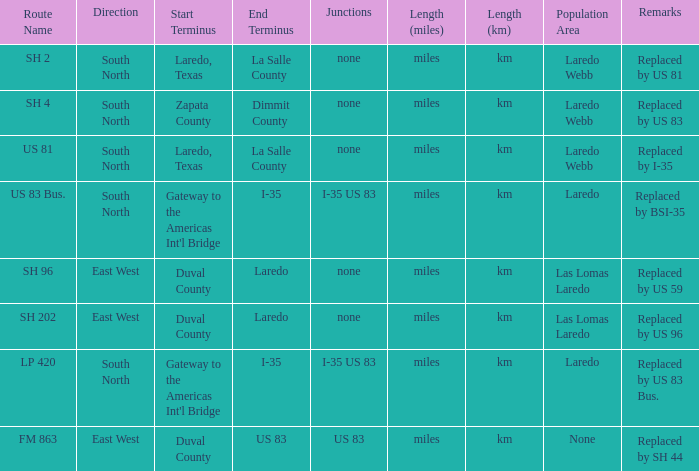How many junctions have "replaced by bsi-35" listed in their remarks section? 1.0. 